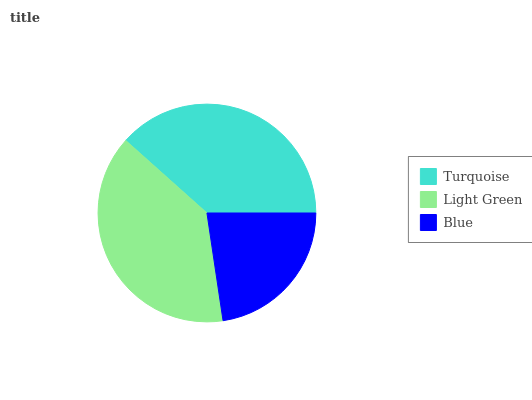Is Blue the minimum?
Answer yes or no. Yes. Is Light Green the maximum?
Answer yes or no. Yes. Is Light Green the minimum?
Answer yes or no. No. Is Blue the maximum?
Answer yes or no. No. Is Light Green greater than Blue?
Answer yes or no. Yes. Is Blue less than Light Green?
Answer yes or no. Yes. Is Blue greater than Light Green?
Answer yes or no. No. Is Light Green less than Blue?
Answer yes or no. No. Is Turquoise the high median?
Answer yes or no. Yes. Is Turquoise the low median?
Answer yes or no. Yes. Is Light Green the high median?
Answer yes or no. No. Is Light Green the low median?
Answer yes or no. No. 